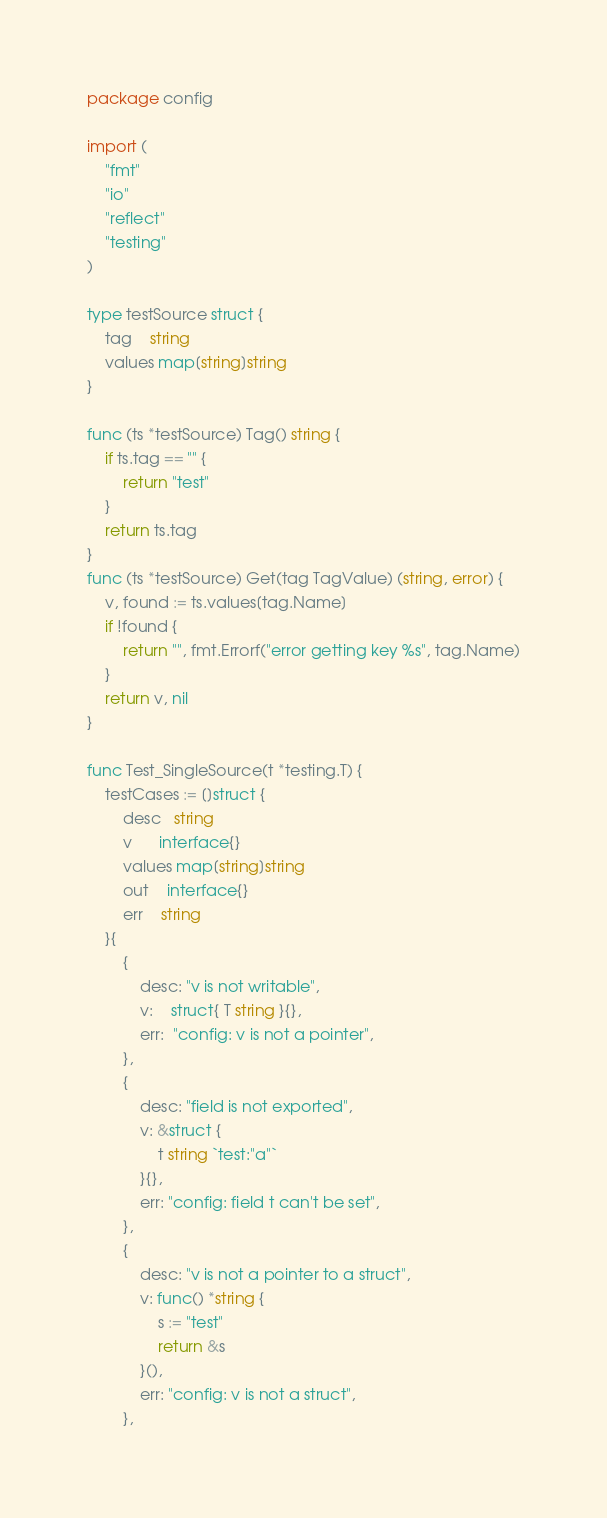Convert code to text. <code><loc_0><loc_0><loc_500><loc_500><_Go_>package config

import (
	"fmt"
	"io"
	"reflect"
	"testing"
)

type testSource struct {
	tag    string
	values map[string]string
}

func (ts *testSource) Tag() string {
	if ts.tag == "" {
		return "test"
	}
	return ts.tag
}
func (ts *testSource) Get(tag TagValue) (string, error) {
	v, found := ts.values[tag.Name]
	if !found {
		return "", fmt.Errorf("error getting key %s", tag.Name)
	}
	return v, nil
}

func Test_SingleSource(t *testing.T) {
	testCases := []struct {
		desc   string
		v      interface{}
		values map[string]string
		out    interface{}
		err    string
	}{
		{
			desc: "v is not writable",
			v:    struct{ T string }{},
			err:  "config: v is not a pointer",
		},
		{
			desc: "field is not exported",
			v: &struct {
				t string `test:"a"`
			}{},
			err: "config: field t can't be set",
		},
		{
			desc: "v is not a pointer to a struct",
			v: func() *string {
				s := "test"
				return &s
			}(),
			err: "config: v is not a struct",
		},</code> 